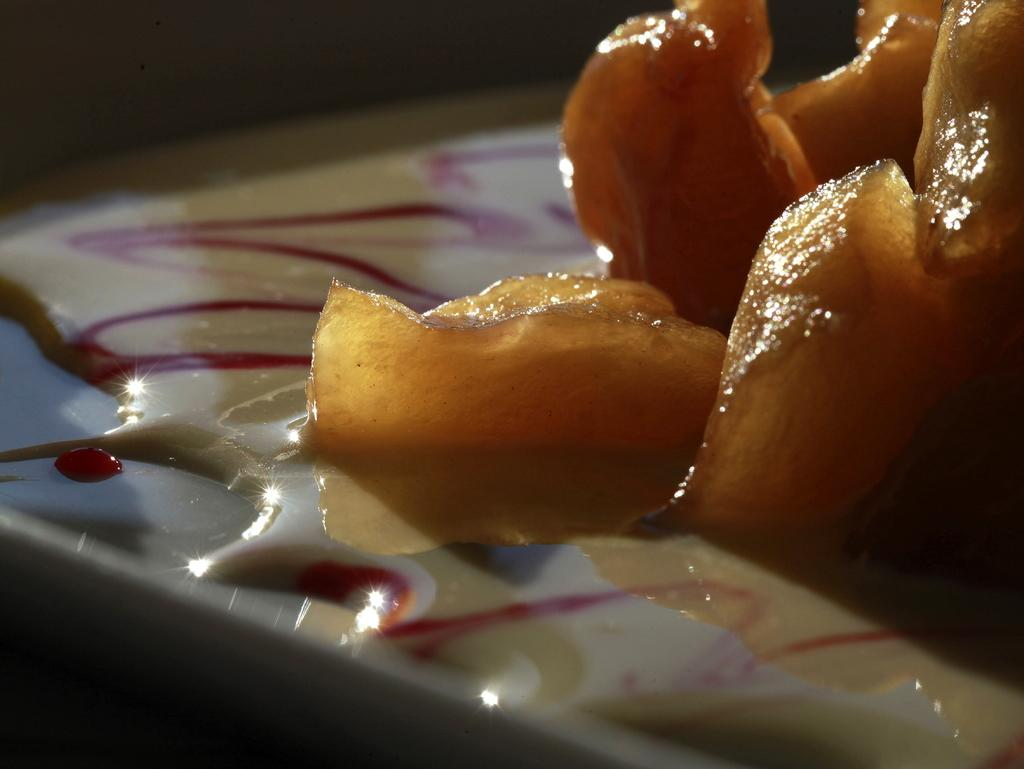What is on the plate that is visible in the image? There is a plate with food in the image. What can be observed about the lighting or color scheme of the image? The background of the image is dark. Where is the tiger sitting in the image? There is no tiger present in the image. What type of seat is visible in the image? There is no seat visible in the image. 